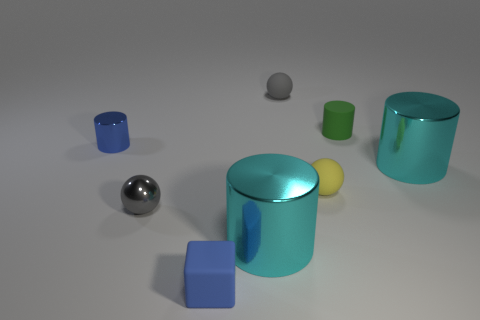What number of yellow objects have the same shape as the gray rubber object?
Offer a terse response. 1. Are there more things on the left side of the blue rubber cube than big blue cubes?
Your answer should be very brief. Yes. What is the shape of the metal thing right of the large metal cylinder that is left of the gray thing right of the small blue rubber cube?
Your answer should be very brief. Cylinder. Do the small metallic thing in front of the small blue shiny cylinder and the thing behind the small green object have the same shape?
Give a very brief answer. Yes. What number of cubes are either small blue shiny objects or gray objects?
Your response must be concise. 0. Is the green cylinder made of the same material as the yellow ball?
Keep it short and to the point. Yes. How many other objects are the same color as the metal sphere?
Offer a terse response. 1. The big cyan metal object on the left side of the green cylinder has what shape?
Provide a succinct answer. Cylinder. How many things are either big blue matte cylinders or large cylinders?
Your answer should be compact. 2. Do the yellow object and the gray thing on the left side of the gray rubber sphere have the same size?
Give a very brief answer. Yes. 